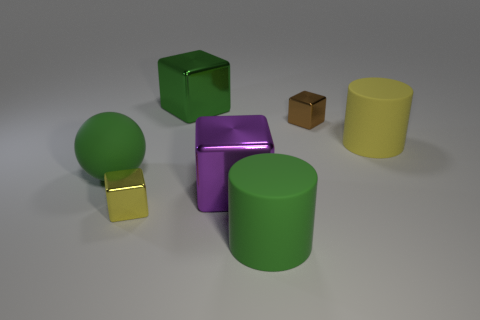Can you describe the colors and shapes of the objects in the image? Certainly! In the image, there are several objects with distinct colors and shapes: a green sphere (a ball), a purple metallic cube, a green cube with a slightly reflective surface, a yellow cylinder, and a small brown cube that looks like a cardboard box. 